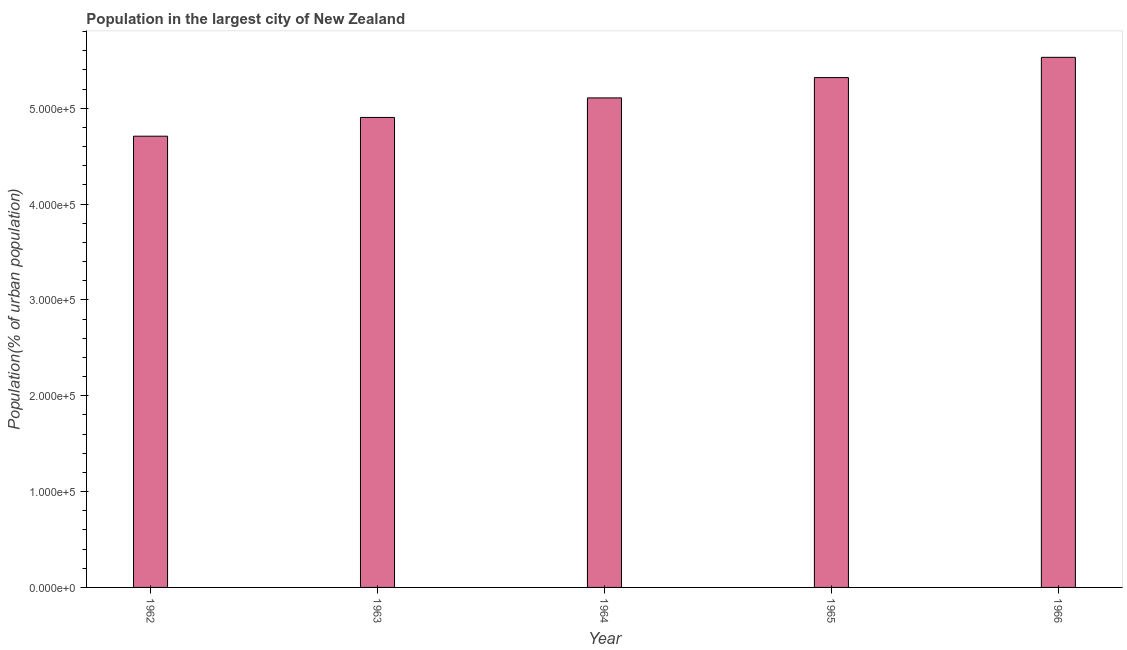Does the graph contain grids?
Your answer should be compact. No. What is the title of the graph?
Make the answer very short. Population in the largest city of New Zealand. What is the label or title of the X-axis?
Your answer should be compact. Year. What is the label or title of the Y-axis?
Offer a terse response. Population(% of urban population). What is the population in largest city in 1962?
Your answer should be very brief. 4.71e+05. Across all years, what is the maximum population in largest city?
Offer a very short reply. 5.53e+05. Across all years, what is the minimum population in largest city?
Make the answer very short. 4.71e+05. In which year was the population in largest city maximum?
Keep it short and to the point. 1966. What is the sum of the population in largest city?
Provide a short and direct response. 2.56e+06. What is the difference between the population in largest city in 1962 and 1964?
Provide a short and direct response. -4.00e+04. What is the average population in largest city per year?
Provide a short and direct response. 5.11e+05. What is the median population in largest city?
Your answer should be compact. 5.11e+05. What is the difference between the highest and the second highest population in largest city?
Ensure brevity in your answer.  2.11e+04. What is the difference between the highest and the lowest population in largest city?
Offer a very short reply. 8.23e+04. Are all the bars in the graph horizontal?
Ensure brevity in your answer.  No. Are the values on the major ticks of Y-axis written in scientific E-notation?
Offer a very short reply. Yes. What is the Population(% of urban population) of 1962?
Your answer should be compact. 4.71e+05. What is the Population(% of urban population) of 1963?
Your answer should be very brief. 4.90e+05. What is the Population(% of urban population) in 1964?
Your answer should be very brief. 5.11e+05. What is the Population(% of urban population) of 1965?
Offer a terse response. 5.32e+05. What is the Population(% of urban population) of 1966?
Make the answer very short. 5.53e+05. What is the difference between the Population(% of urban population) in 1962 and 1963?
Give a very brief answer. -1.96e+04. What is the difference between the Population(% of urban population) in 1962 and 1964?
Provide a short and direct response. -4.00e+04. What is the difference between the Population(% of urban population) in 1962 and 1965?
Provide a succinct answer. -6.12e+04. What is the difference between the Population(% of urban population) in 1962 and 1966?
Ensure brevity in your answer.  -8.23e+04. What is the difference between the Population(% of urban population) in 1963 and 1964?
Your answer should be very brief. -2.04e+04. What is the difference between the Population(% of urban population) in 1963 and 1965?
Offer a terse response. -4.16e+04. What is the difference between the Population(% of urban population) in 1963 and 1966?
Provide a succinct answer. -6.27e+04. What is the difference between the Population(% of urban population) in 1964 and 1965?
Offer a very short reply. -2.12e+04. What is the difference between the Population(% of urban population) in 1964 and 1966?
Offer a terse response. -4.23e+04. What is the difference between the Population(% of urban population) in 1965 and 1966?
Make the answer very short. -2.11e+04. What is the ratio of the Population(% of urban population) in 1962 to that in 1964?
Provide a succinct answer. 0.92. What is the ratio of the Population(% of urban population) in 1962 to that in 1965?
Your answer should be very brief. 0.89. What is the ratio of the Population(% of urban population) in 1962 to that in 1966?
Your answer should be very brief. 0.85. What is the ratio of the Population(% of urban population) in 1963 to that in 1965?
Your response must be concise. 0.92. What is the ratio of the Population(% of urban population) in 1963 to that in 1966?
Your answer should be compact. 0.89. What is the ratio of the Population(% of urban population) in 1964 to that in 1966?
Give a very brief answer. 0.92. 